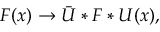Convert formula to latex. <formula><loc_0><loc_0><loc_500><loc_500>F ( x ) \to \bar { U } * F * U ( x ) ,</formula> 